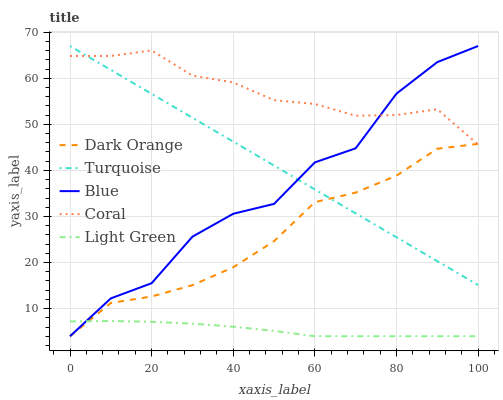Does Light Green have the minimum area under the curve?
Answer yes or no. Yes. Does Coral have the maximum area under the curve?
Answer yes or no. Yes. Does Dark Orange have the minimum area under the curve?
Answer yes or no. No. Does Dark Orange have the maximum area under the curve?
Answer yes or no. No. Is Turquoise the smoothest?
Answer yes or no. Yes. Is Blue the roughest?
Answer yes or no. Yes. Is Dark Orange the smoothest?
Answer yes or no. No. Is Dark Orange the roughest?
Answer yes or no. No. Does Turquoise have the lowest value?
Answer yes or no. No. Does Turquoise have the highest value?
Answer yes or no. Yes. Does Dark Orange have the highest value?
Answer yes or no. No. Is Light Green less than Turquoise?
Answer yes or no. Yes. Is Turquoise greater than Light Green?
Answer yes or no. Yes. Does Dark Orange intersect Coral?
Answer yes or no. Yes. Is Dark Orange less than Coral?
Answer yes or no. No. Is Dark Orange greater than Coral?
Answer yes or no. No. Does Light Green intersect Turquoise?
Answer yes or no. No. 